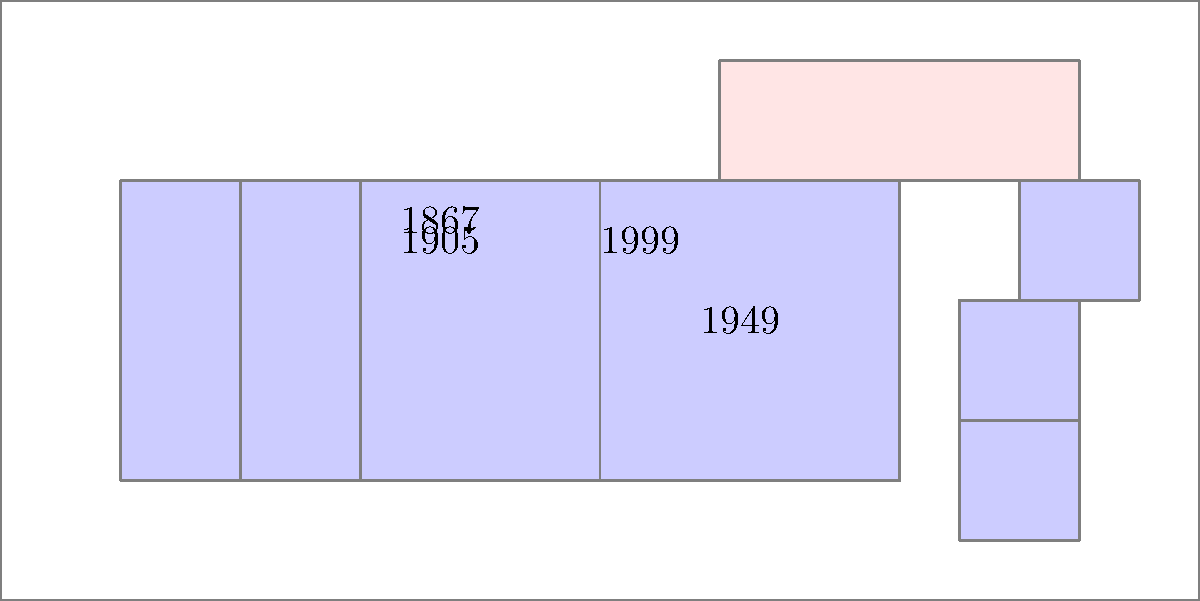Based on the series of maps depicting changes in Canadian territory boundaries from Confederation to present day, which province joined Canada most recently, and in what year did this occur? To answer this question, we need to analyze the map series chronologically:

1. The map labeled "1867" shows the original four provinces at Confederation: Ontario, Quebec, Nova Scotia, and New Brunswick.

2. The map labeled "1905" indicates the addition of two new provinces: Alberta and Saskatchewan.

3. The map labeled "1949" shows a new addition in the east, which represents Newfoundland (now Newfoundland and Labrador).

4. The final change shown is labeled "1999", but this represents the creation of Nunavut as a territory, not the addition of a new province.

By examining these changes, we can determine that the most recent addition of a province to Canada, as shown in this map series, was Newfoundland in 1949.

It's important to note that while Nunavut was created more recently (1999), it is a territory, not a province, so it does not qualify as the correct answer to this specific question.
Answer: Newfoundland, 1949 